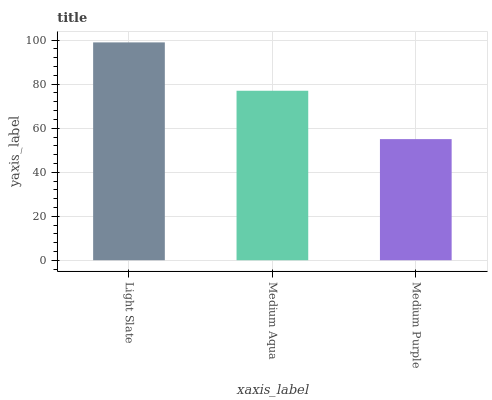Is Medium Purple the minimum?
Answer yes or no. Yes. Is Light Slate the maximum?
Answer yes or no. Yes. Is Medium Aqua the minimum?
Answer yes or no. No. Is Medium Aqua the maximum?
Answer yes or no. No. Is Light Slate greater than Medium Aqua?
Answer yes or no. Yes. Is Medium Aqua less than Light Slate?
Answer yes or no. Yes. Is Medium Aqua greater than Light Slate?
Answer yes or no. No. Is Light Slate less than Medium Aqua?
Answer yes or no. No. Is Medium Aqua the high median?
Answer yes or no. Yes. Is Medium Aqua the low median?
Answer yes or no. Yes. Is Medium Purple the high median?
Answer yes or no. No. Is Light Slate the low median?
Answer yes or no. No. 